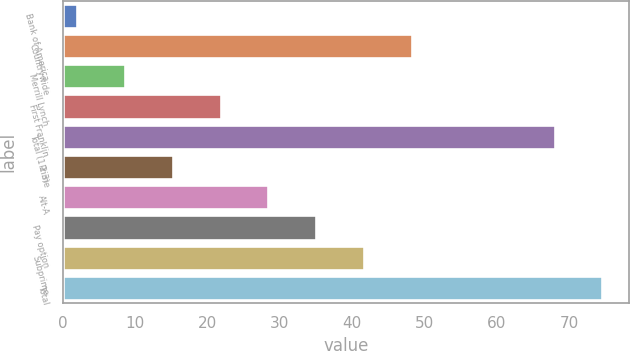Convert chart to OTSL. <chart><loc_0><loc_0><loc_500><loc_500><bar_chart><fcel>Bank of America<fcel>Countrywide<fcel>Merrill Lynch<fcel>First Franklin<fcel>Total (1 2 3)<fcel>Prime<fcel>Alt-A<fcel>Pay option<fcel>Subprime<fcel>Total<nl><fcel>2<fcel>48.2<fcel>8.6<fcel>21.8<fcel>68<fcel>15.2<fcel>28.4<fcel>35<fcel>41.6<fcel>74.6<nl></chart> 